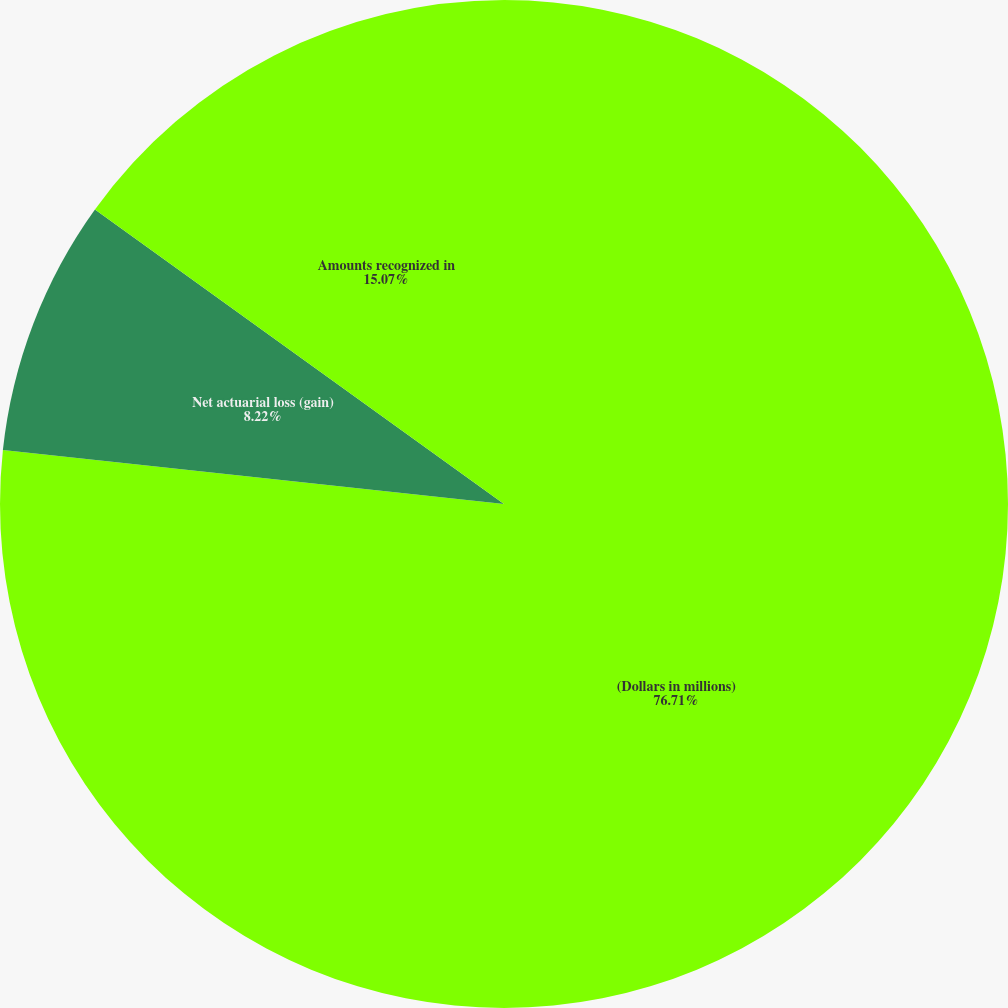Convert chart. <chart><loc_0><loc_0><loc_500><loc_500><pie_chart><fcel>(Dollars in millions)<fcel>Net actuarial loss (gain)<fcel>Amounts recognized in<nl><fcel>76.71%<fcel>8.22%<fcel>15.07%<nl></chart> 